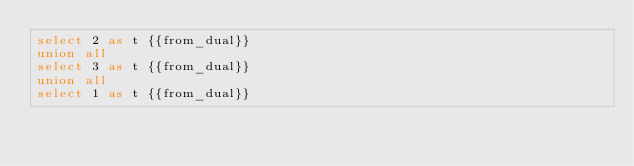<code> <loc_0><loc_0><loc_500><loc_500><_SQL_>select 2 as t {{from_dual}}
union all
select 3 as t {{from_dual}}
union all
select 1 as t {{from_dual}}
</code> 